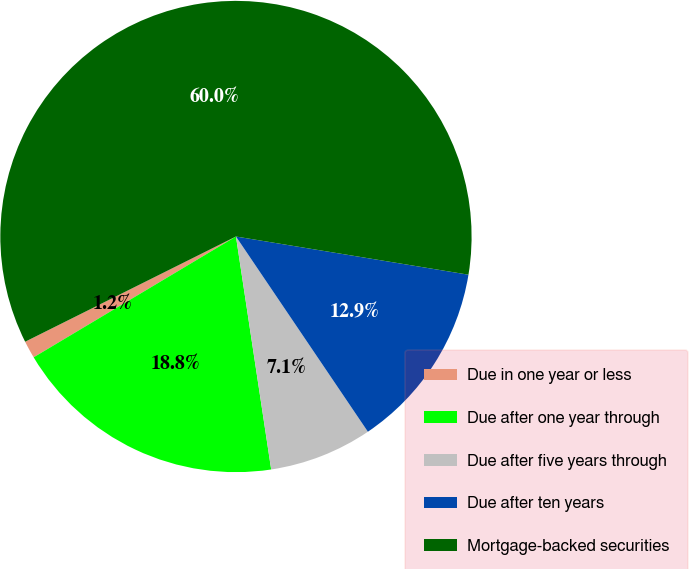Convert chart to OTSL. <chart><loc_0><loc_0><loc_500><loc_500><pie_chart><fcel>Due in one year or less<fcel>Due after one year through<fcel>Due after five years through<fcel>Due after ten years<fcel>Mortgage-backed securities<nl><fcel>1.2%<fcel>18.82%<fcel>7.07%<fcel>12.95%<fcel>59.96%<nl></chart> 